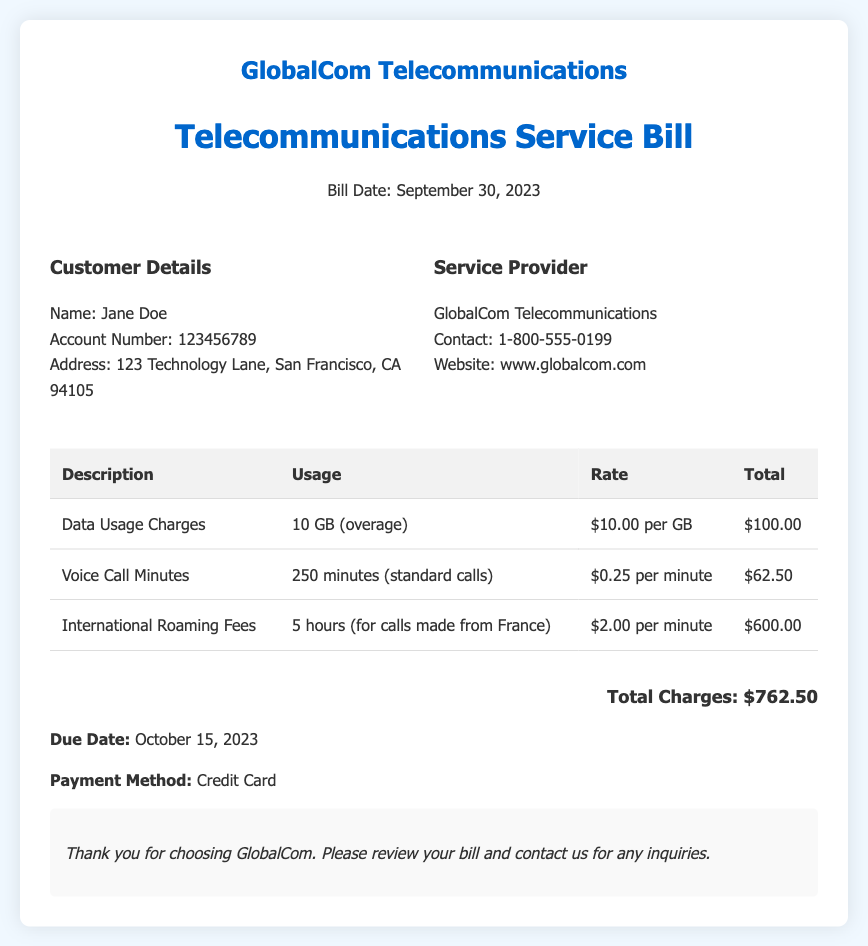What is the bill date? The bill date is stated in the header of the document as September 30, 2023.
Answer: September 30, 2023 What is the name of the customer? The customer's name is provided in the Customer Details section of the bill.
Answer: Jane Doe What is the total charge amount? The total charge amount is summarized at the bottom of the bill.
Answer: $762.50 How many gigabytes of data were used? The data usage charges specify that 10 GB were used as overage.
Answer: 10 GB What is the rate per international roaming minute? The document outlines the rate for international roaming fees per minute in the corresponding table.
Answer: $2.00 per minute What is the due date for payment? The due date for payment is mentioned clearly toward the end of the bill.
Answer: October 15, 2023 How many call minutes were used? The voice call minutes charge details indicate the total minutes used.
Answer: 250 minutes What is the payment method? The payment method is stated toward the end of the bill document.
Answer: Credit Card What is the total charge for international roaming? The international roaming fees section specifies the total charge amount.
Answer: $600.00 